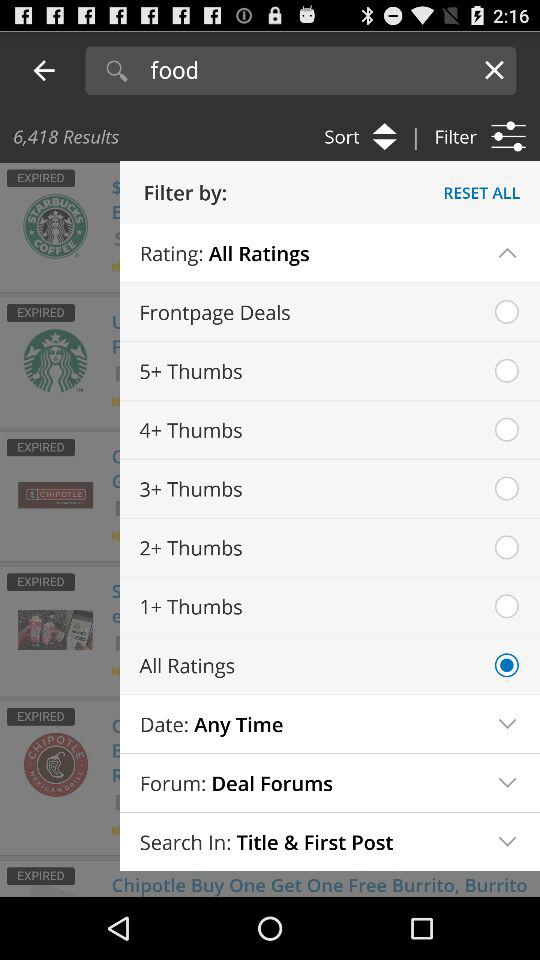What is written in the search field? In the search field, "food" is written. 